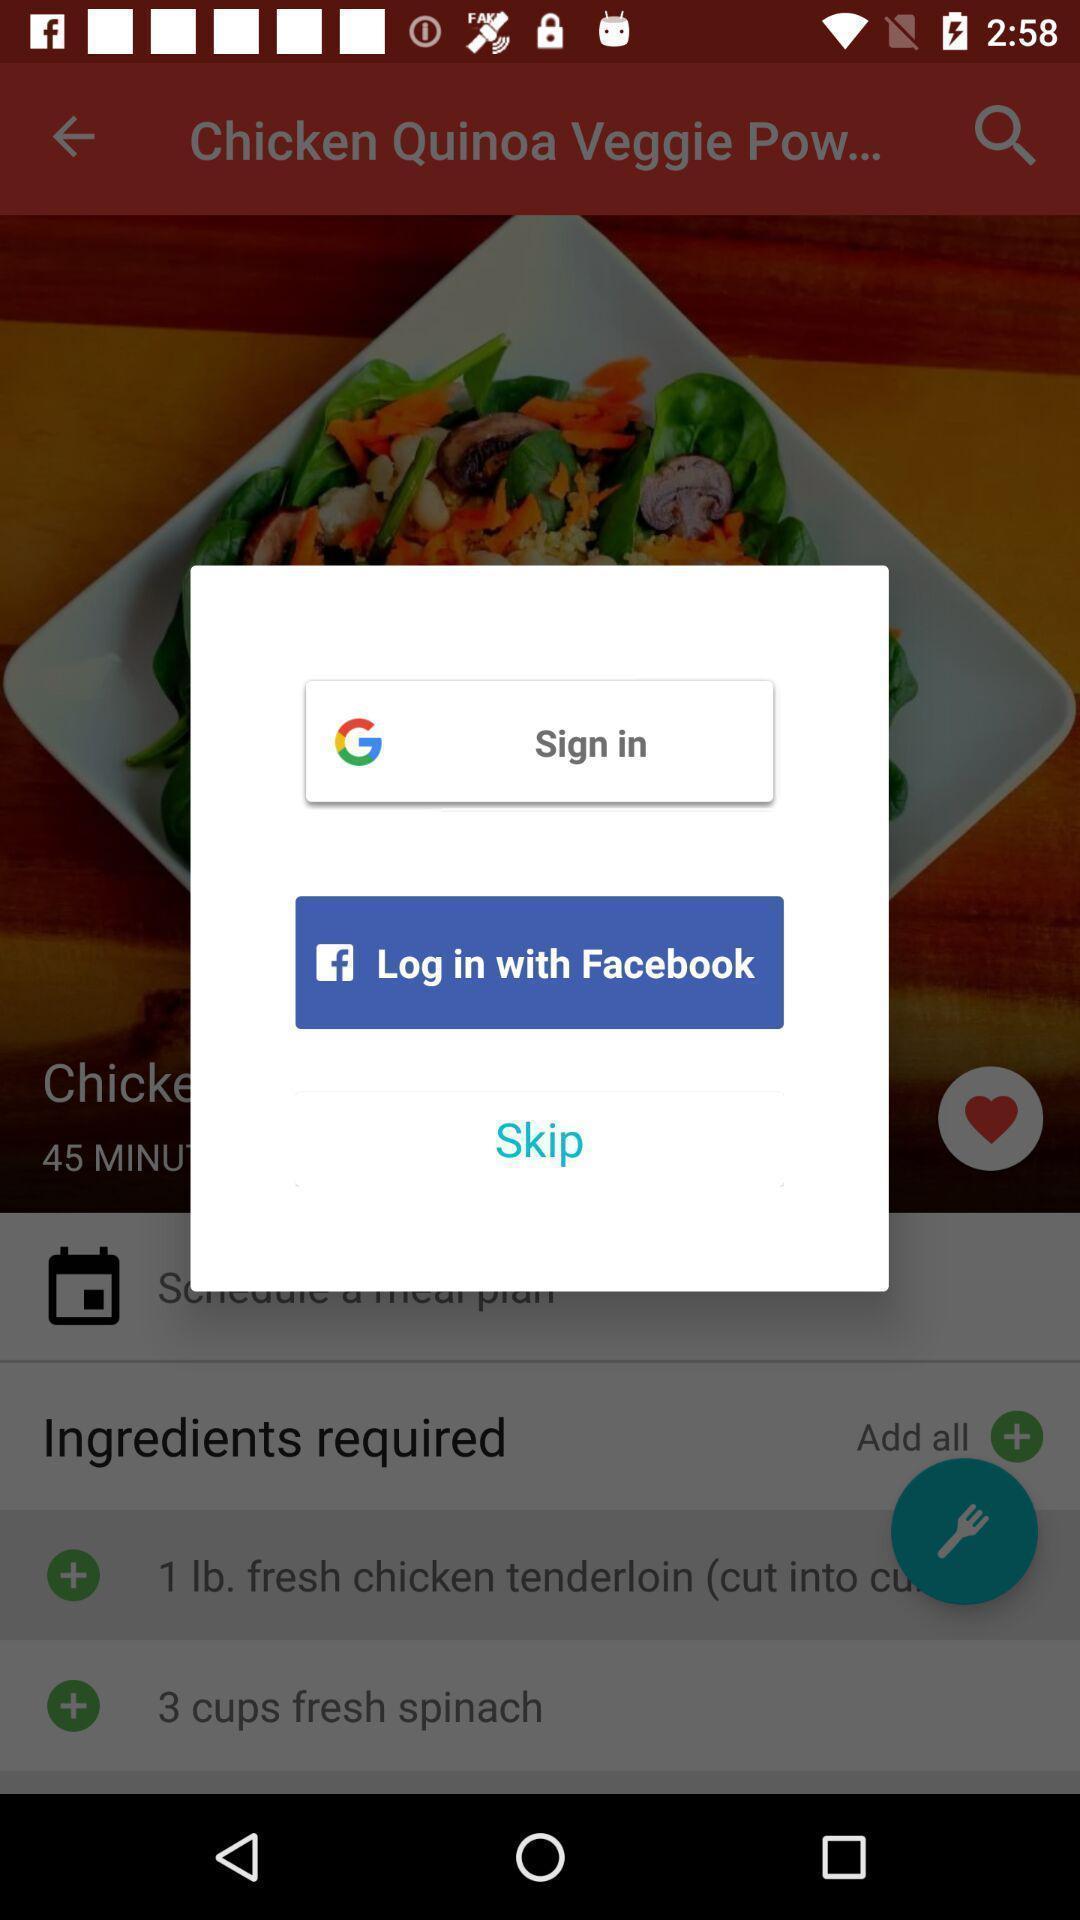Explain what's happening in this screen capture. Signing into food app through different login domains. 